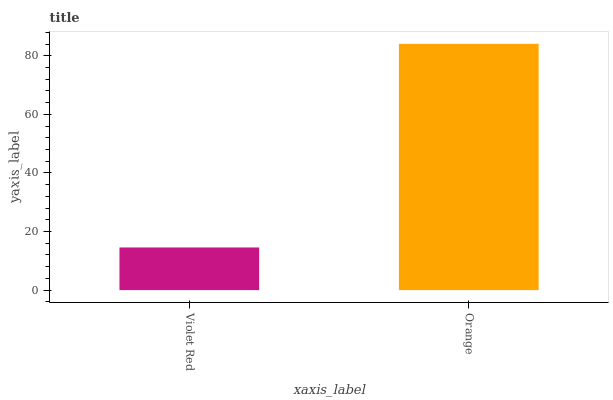Is Violet Red the minimum?
Answer yes or no. Yes. Is Orange the maximum?
Answer yes or no. Yes. Is Orange the minimum?
Answer yes or no. No. Is Orange greater than Violet Red?
Answer yes or no. Yes. Is Violet Red less than Orange?
Answer yes or no. Yes. Is Violet Red greater than Orange?
Answer yes or no. No. Is Orange less than Violet Red?
Answer yes or no. No. Is Orange the high median?
Answer yes or no. Yes. Is Violet Red the low median?
Answer yes or no. Yes. Is Violet Red the high median?
Answer yes or no. No. Is Orange the low median?
Answer yes or no. No. 